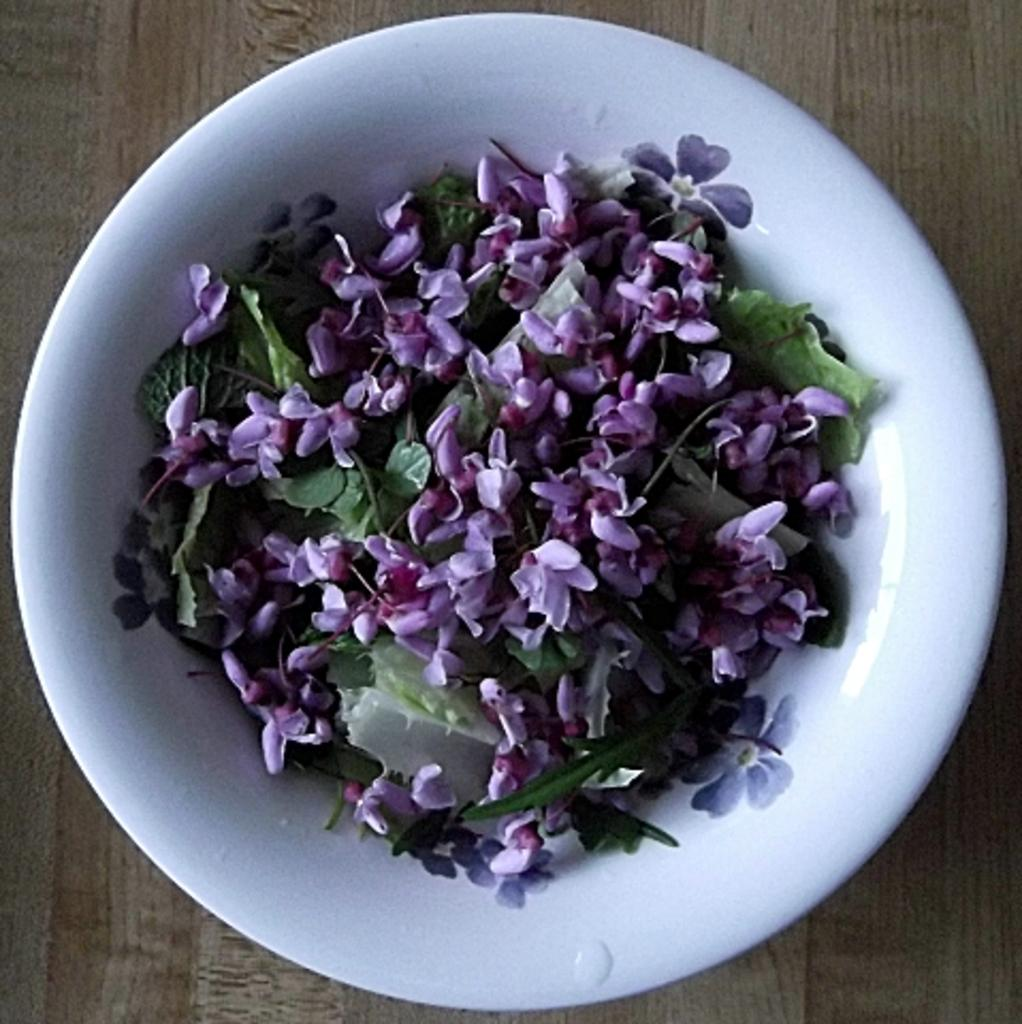What is located on the surface in the image? There is a bowl on a surface in the image. What is inside the bowl? The bowl contains leaves and flowers. What is the mass of the hope depicted in the image? There is no depiction of hope in the image, and therefore no mass can be determined. 